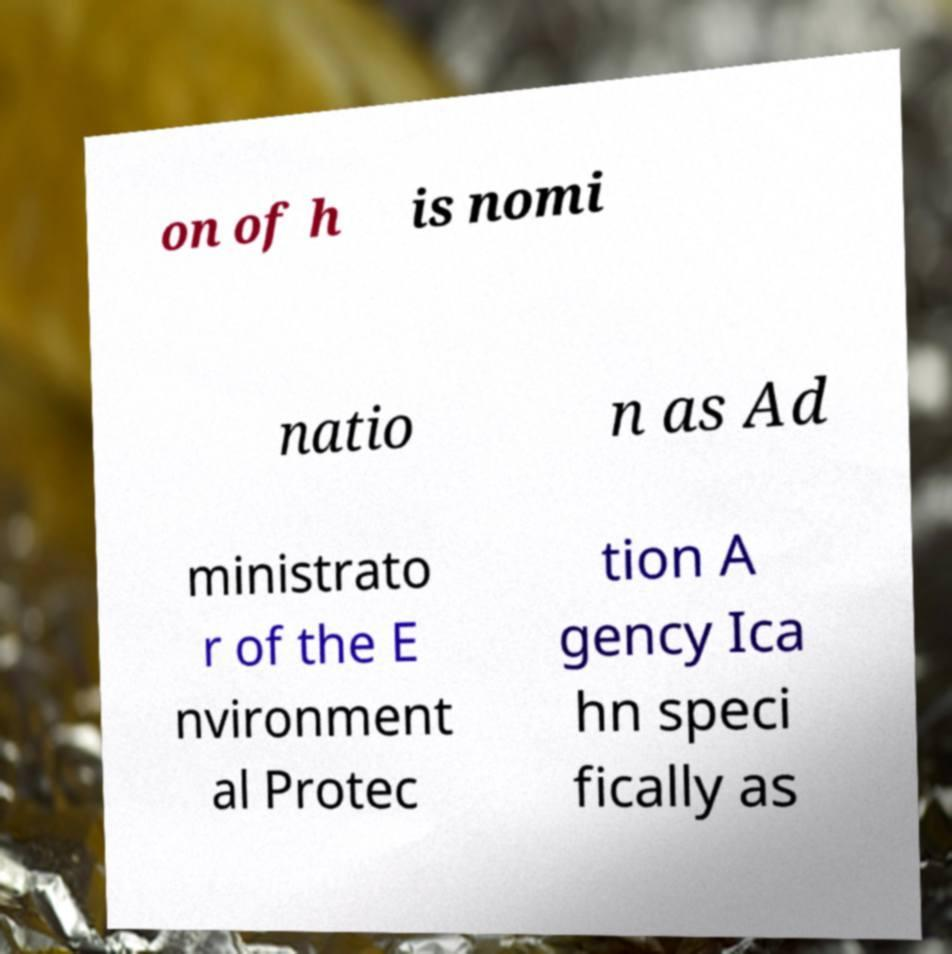Could you assist in decoding the text presented in this image and type it out clearly? on of h is nomi natio n as Ad ministrato r of the E nvironment al Protec tion A gency Ica hn speci fically as 